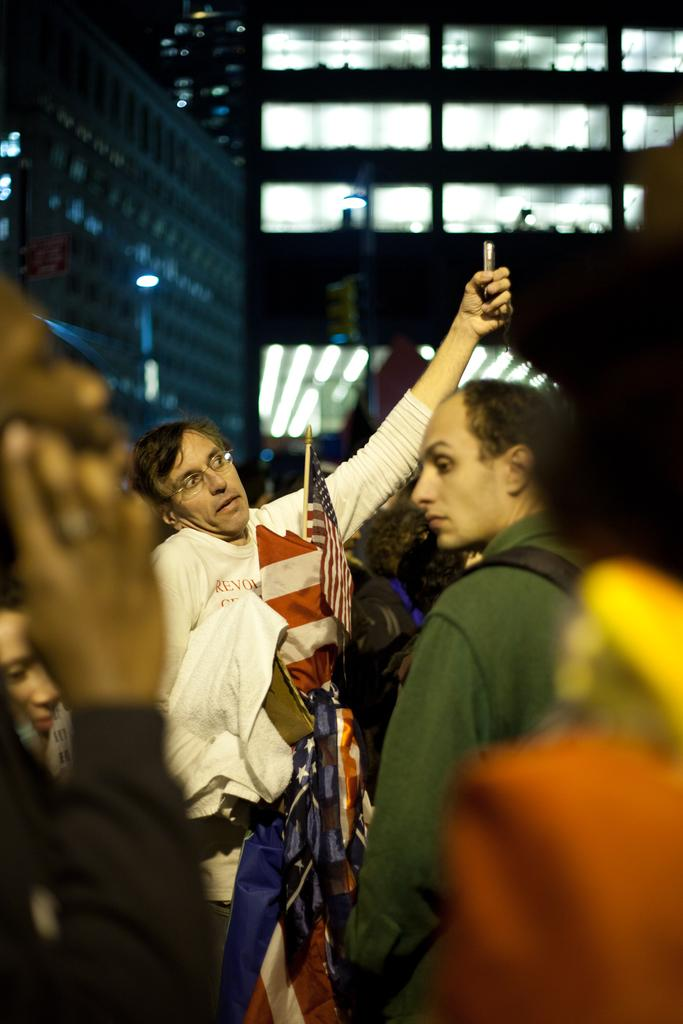What can be seen at the bottom of the image? There are people standing at the bottom of the image. What are the people holding in their hands? The people are holding something in their hands. What can be seen in the distance in the image? There are buildings visible in the background of the image. What type of frame is used to hold the paint in the image? There is no frame or paint present in the image. What color is the flame in the image? There is no flame present in the image. 